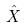<formula> <loc_0><loc_0><loc_500><loc_500>\hat { X }</formula> 